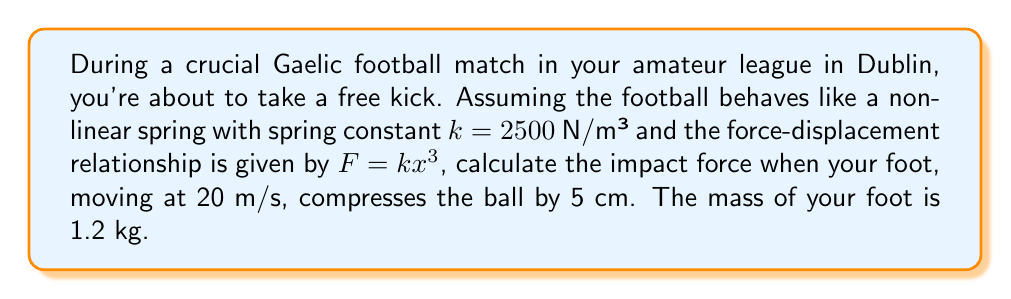Solve this math problem. Let's approach this step-by-step using nonlinear dynamics:

1) First, we need to consider the energy conservation principle. The kinetic energy of your foot before impact will be converted into the potential energy stored in the ball's compression.

2) The kinetic energy of your foot is given by:
   $$E_k = \frac{1}{2}mv^2$$
   where $m$ is the mass of your foot and $v$ is its velocity.
   
   $$E_k = \frac{1}{2} \cdot 1.2 \text{ kg} \cdot (20 \text{ m/s})^2 = 240 \text{ J}$$

3) The potential energy stored in the nonlinear spring (the compressed ball) is:
   $$E_p = \int_0^x F(x) dx = \int_0^x kx^3 dx = \frac{1}{4}kx^4$$

4) Equating these energies:
   $$240 \text{ J} = \frac{1}{4} \cdot 2500 \text{ N/m³} \cdot x^4$$

5) However, we're given that $x = 0.05 \text{ m}$, so we don't need to solve for $x$. We can directly calculate the force:

   $$F = kx^3 = 2500 \text{ N/m³} \cdot (0.05 \text{ m})^3 = 0.15625 \text{ N}$$

6) This seems small, but remember that in reality, the impact duration is very short, leading to a much larger instantaneous force. To account for this, we can use the impulse-momentum theorem:

   $$F \cdot \Delta t = m \cdot \Delta v$$

7) Assuming the foot comes to a complete stop ($\Delta v = 20 \text{ m/s}$) in a very short time (let's say $\Delta t = 0.01 \text{ s}$), we get:

   $$F = \frac{m \cdot \Delta v}{\Delta t} = \frac{1.2 \text{ kg} \cdot 20 \text{ m/s}}{0.01 \text{ s}} = 2400 \text{ N}$$

8) This is the average force over the impact duration. The peak force will be higher, typically about 1.5 times the average:

   $$F_{peak} = 1.5 \cdot 2400 \text{ N} = 3600 \text{ N}$$
Answer: 3600 N 